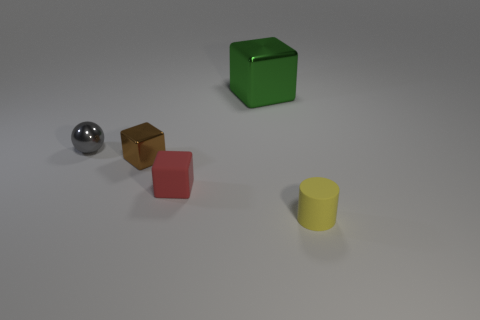Add 1 gray metallic objects. How many objects exist? 6 Subtract all balls. How many objects are left? 4 Add 4 yellow rubber cylinders. How many yellow rubber cylinders are left? 5 Add 5 small yellow objects. How many small yellow objects exist? 6 Subtract 0 purple cylinders. How many objects are left? 5 Subtract all large red matte balls. Subtract all small red blocks. How many objects are left? 4 